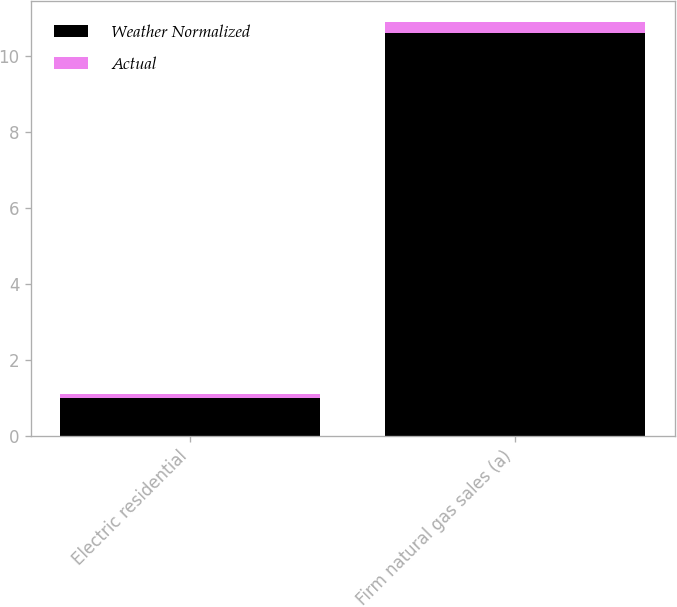<chart> <loc_0><loc_0><loc_500><loc_500><stacked_bar_chart><ecel><fcel>Electric residential<fcel>Firm natural gas sales (a)<nl><fcel>Weather Normalized<fcel>1<fcel>10.6<nl><fcel>Actual<fcel>0.1<fcel>0.3<nl></chart> 